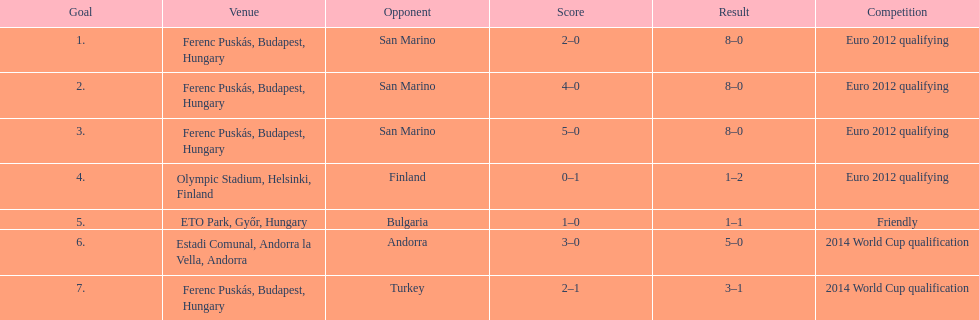Excluding one goal, szalai scored all his international goals in euro 2012 qualifying and which other competition level? 2014 World Cup qualification. 